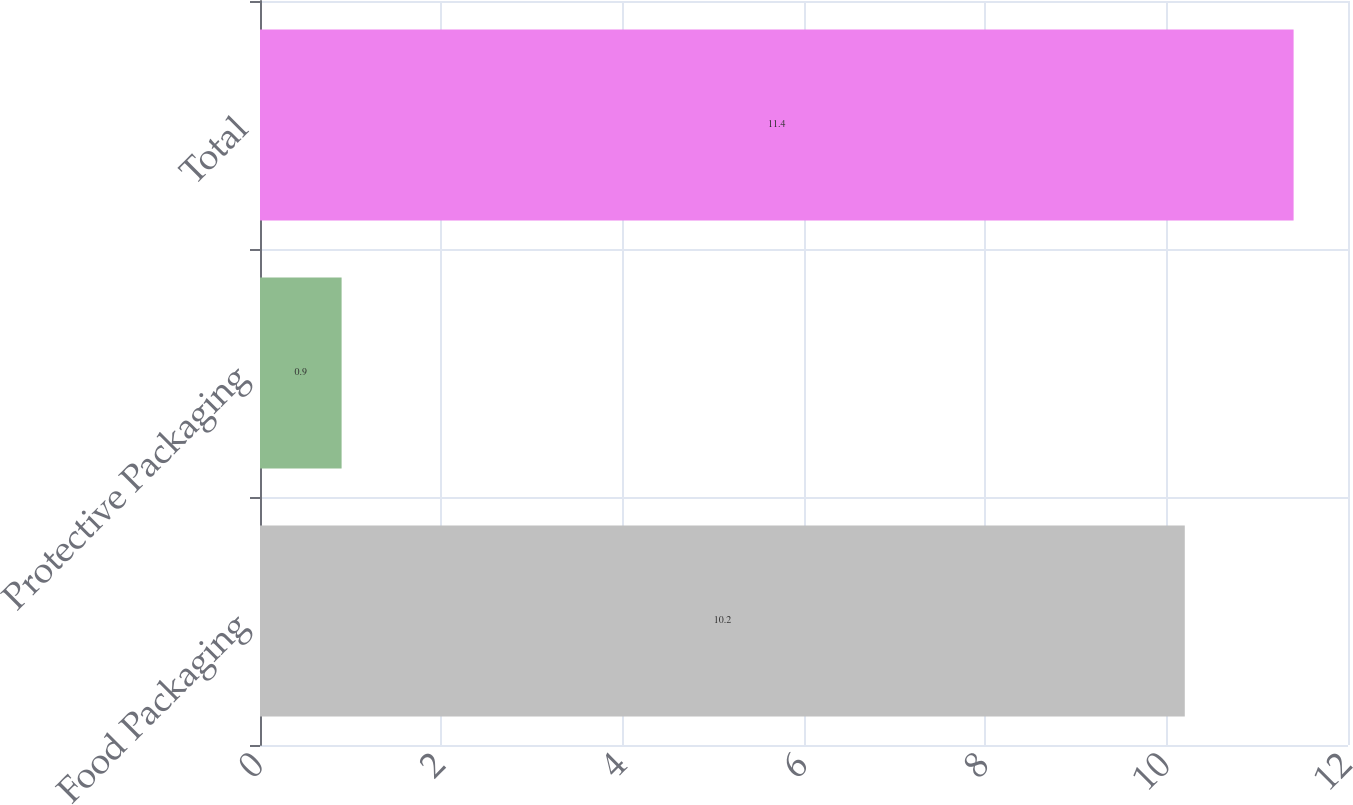<chart> <loc_0><loc_0><loc_500><loc_500><bar_chart><fcel>Food Packaging<fcel>Protective Packaging<fcel>Total<nl><fcel>10.2<fcel>0.9<fcel>11.4<nl></chart> 